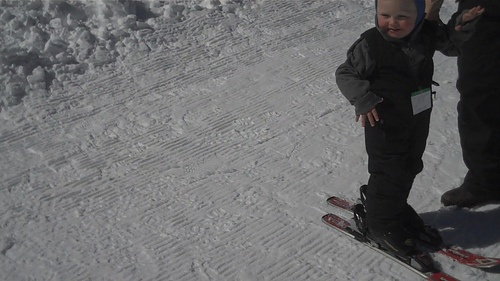Describe the objects in this image and their specific colors. I can see people in gray and black tones, people in gray and black tones, skis in gray, black, and maroon tones, and skis in gray, maroon, and black tones in this image. 